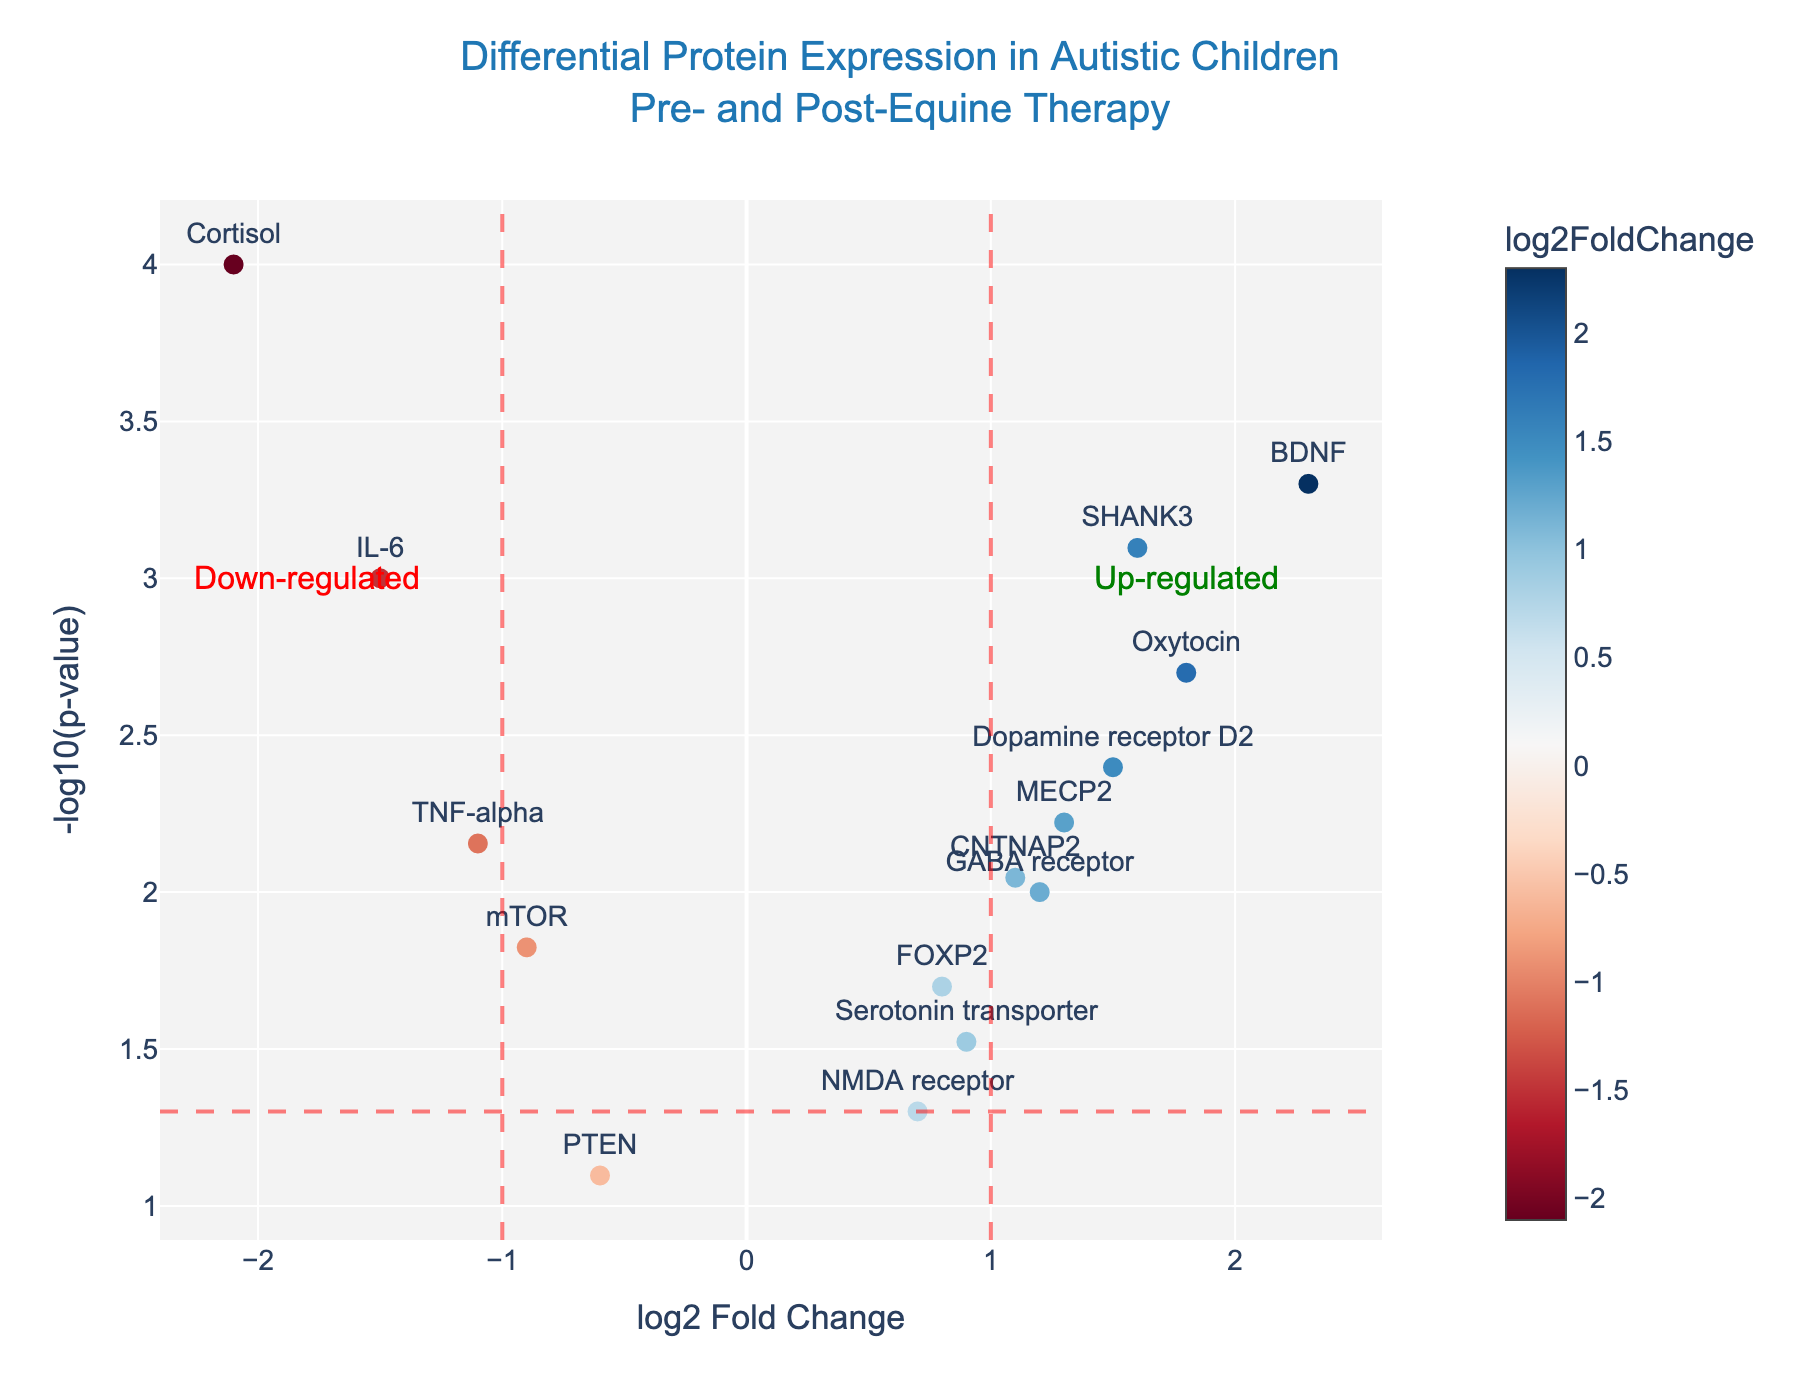how many proteins were examined in the study? By counting the number of points on the plot, each representing a protein, we can determine the total number of proteins examined.
Answer: 15 Which protein has the highest log2 fold change? The protein with the highest log2 fold change will be the one whose point is farthest to the right on the x-axis.
Answer: BDNF Which protein has the smallest p-value? The protein with the smallest p-value can be found by identifying the point highest on the y-axis, since -log10(p-value) increases as p-value decreases.
Answer: Cortisol How many proteins exhibit up-regulation after equine therapy? Up-regulated proteins will have positive log2 fold change values and their points will be to the right of the x=0 line. Count these points.
Answer: 9 How many proteins are significantly down-regulated based on the plot? Significantly down-regulated proteins will have log2 fold change less than -1 and their points will be to the left of the x=-1 line, and above the y=-log10(0.05) line. Count these points.
Answer: 2 What is the log2 fold change and p-value for the SHANK3 protein? Look for the point labeled 'SHANK3' and read its coordinates: x-axis for log2 fold change and y-axis to infer the p-value using -log10 scale.
Answer: log2FC: 1.6, p-value: 8e-4 Which proteins are neither significantly up-regulated nor down-regulated? These proteins will have log2 fold changes between -1 and 1 and p-values greater than 0.05, which means their points are outside the significant thresholds marked by the lines.
Answer: NMDA receptor, PTEN Is the expression of the GABA receptor protein increased or decreased after equine therapy? Check the log2 fold change value for the GABA receptor; if it is positive, it indicates increased expression.
Answer: Increased What is the average log2 fold change among all analyzed proteins? Sum all the log2 fold change values and divide by the number of proteins to get the average. (-1.5 + 2.3 + 1.8 -2.1 + 1.2 + 0.9 -1.1 + 1.5 + 0.7 + 1.3 + 0.8 + 1.6 -0.6 + 1.1 -0.9) / 15
Answer: 0.56 Which protein has the highest significance level indicated by the y-axis? Identify the point that is highest on the y-axis.
Answer: Cortisol 